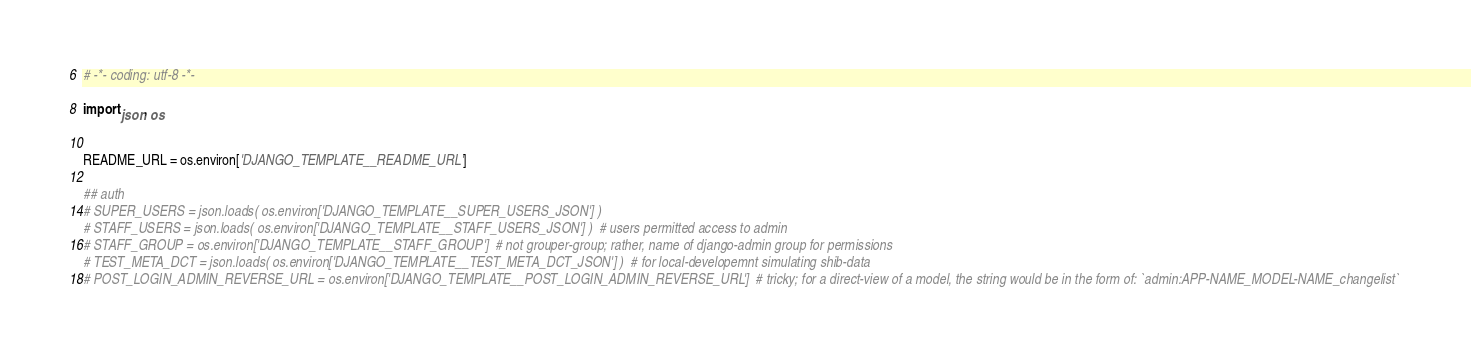<code> <loc_0><loc_0><loc_500><loc_500><_Python_># -*- coding: utf-8 -*-

import json, os


README_URL = os.environ['DJANGO_TEMPLATE__README_URL']

## auth
# SUPER_USERS = json.loads( os.environ['DJANGO_TEMPLATE__SUPER_USERS_JSON'] )
# STAFF_USERS = json.loads( os.environ['DJANGO_TEMPLATE__STAFF_USERS_JSON'] )  # users permitted access to admin
# STAFF_GROUP = os.environ['DJANGO_TEMPLATE__STAFF_GROUP']  # not grouper-group; rather, name of django-admin group for permissions
# TEST_META_DCT = json.loads( os.environ['DJANGO_TEMPLATE__TEST_META_DCT_JSON'] )  # for local-developemnt simulating shib-data
# POST_LOGIN_ADMIN_REVERSE_URL = os.environ['DJANGO_TEMPLATE__POST_LOGIN_ADMIN_REVERSE_URL']  # tricky; for a direct-view of a model, the string would be in the form of: `admin:APP-NAME_MODEL-NAME_changelist`
</code> 